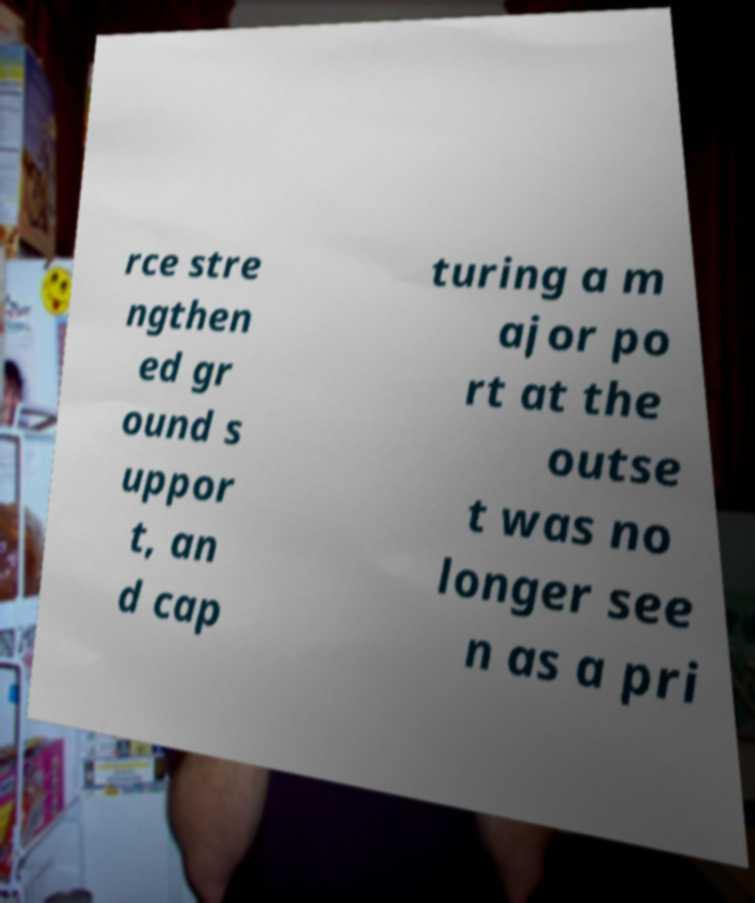There's text embedded in this image that I need extracted. Can you transcribe it verbatim? rce stre ngthen ed gr ound s uppor t, an d cap turing a m ajor po rt at the outse t was no longer see n as a pri 